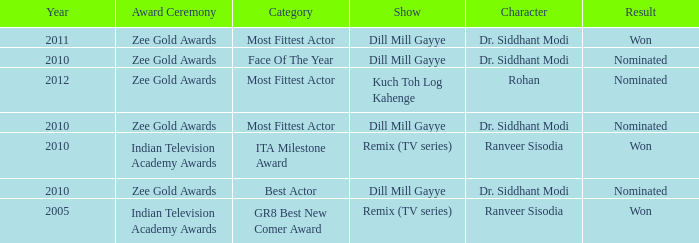Which show was nominated for the ITA Milestone Award at the Indian Television Academy Awards? Remix (TV series). 